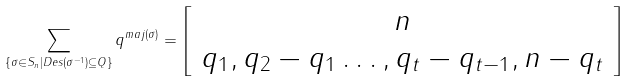Convert formula to latex. <formula><loc_0><loc_0><loc_500><loc_500>\sum _ { \{ \sigma \in S _ { n } | D e s ( \sigma ^ { - 1 } ) \subseteq Q \} } q ^ { m a j ( \sigma ) } = \left [ \begin{array} { c } n \\ q _ { 1 } , q _ { 2 } - q _ { 1 } \dots , q _ { t } - q _ { t - 1 } , n - q _ { t } \end{array} \right ]</formula> 